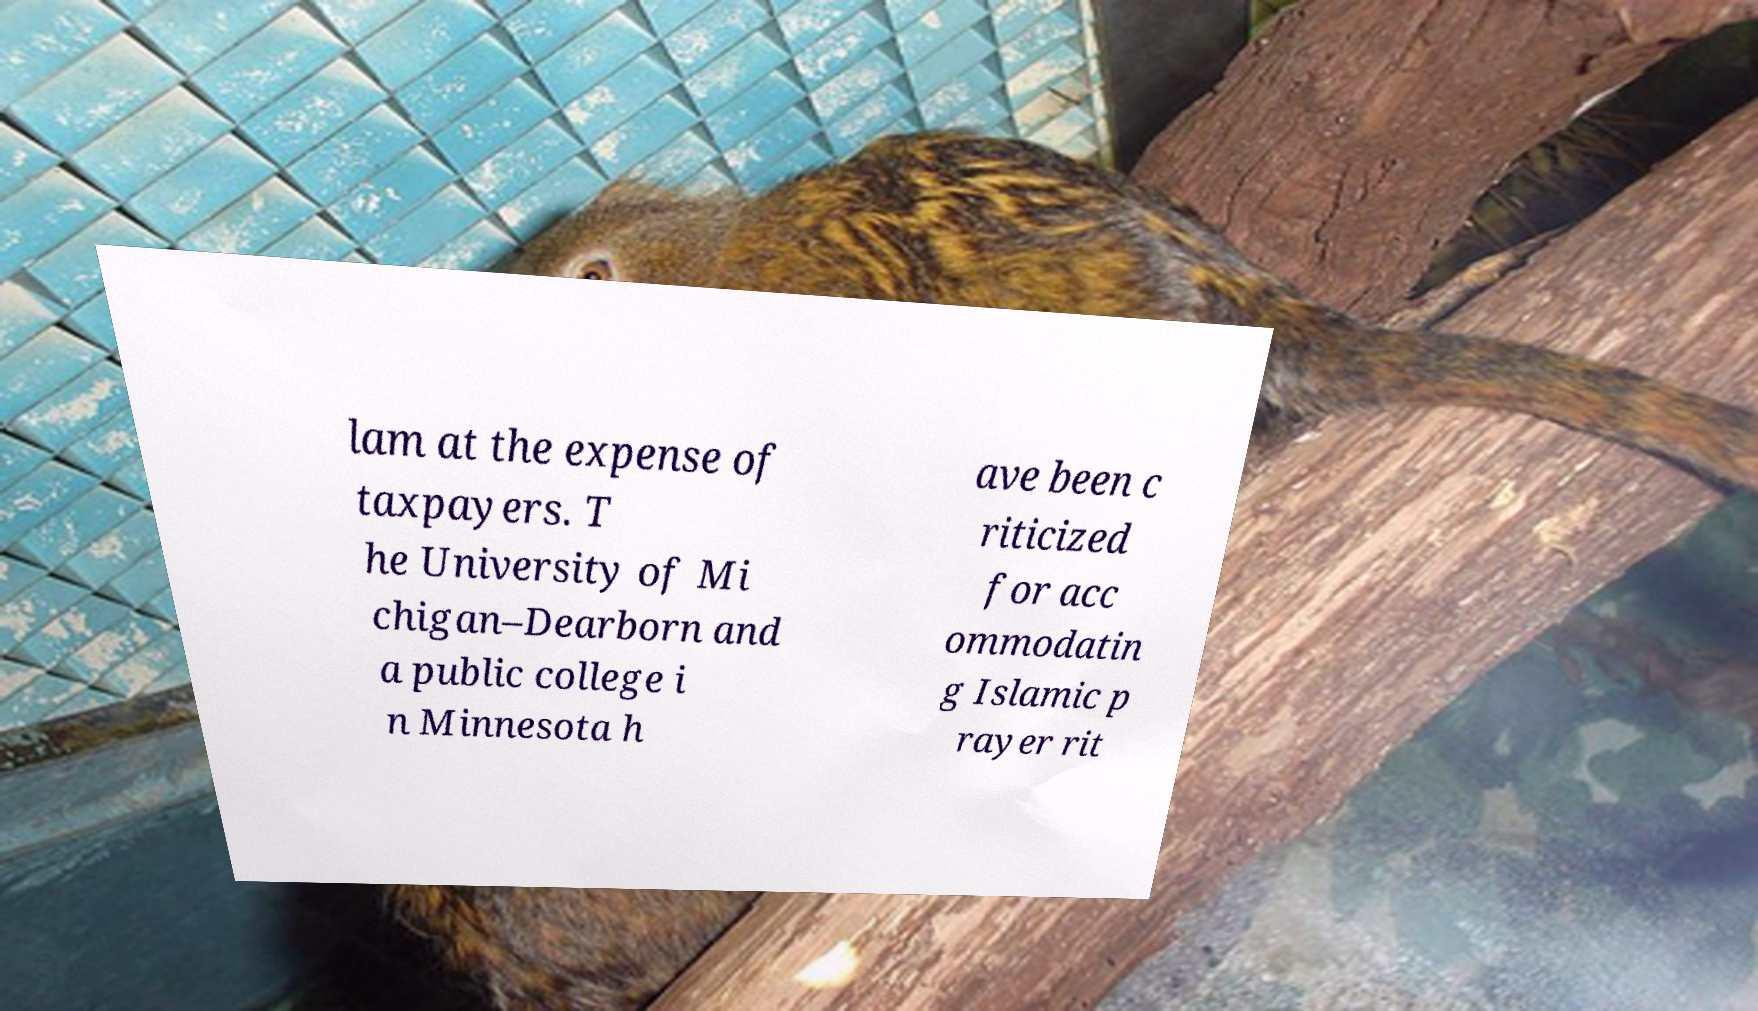Could you extract and type out the text from this image? lam at the expense of taxpayers. T he University of Mi chigan–Dearborn and a public college i n Minnesota h ave been c riticized for acc ommodatin g Islamic p rayer rit 